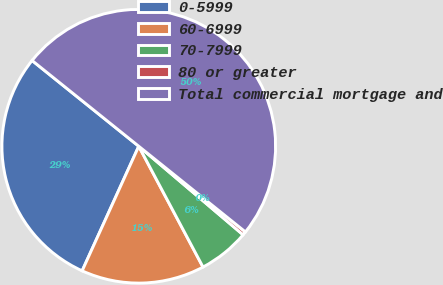Convert chart to OTSL. <chart><loc_0><loc_0><loc_500><loc_500><pie_chart><fcel>0-5999<fcel>60-6999<fcel>70-7999<fcel>80 or greater<fcel>Total commercial mortgage and<nl><fcel>28.99%<fcel>14.57%<fcel>6.02%<fcel>0.43%<fcel>50.0%<nl></chart> 